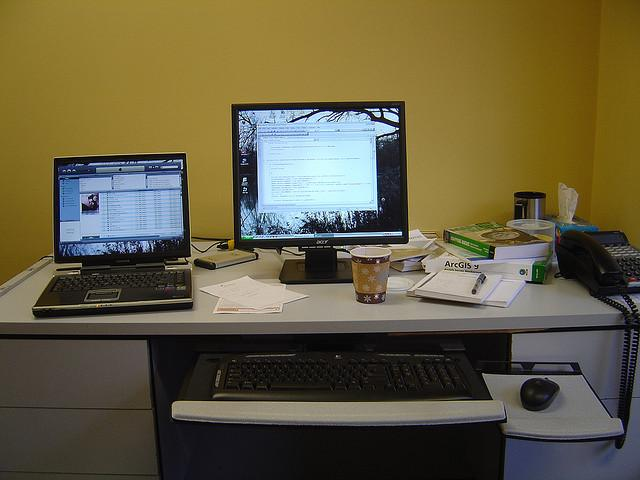Why would someone sit here? Please explain your reasoning. to work. The desk is for working. 